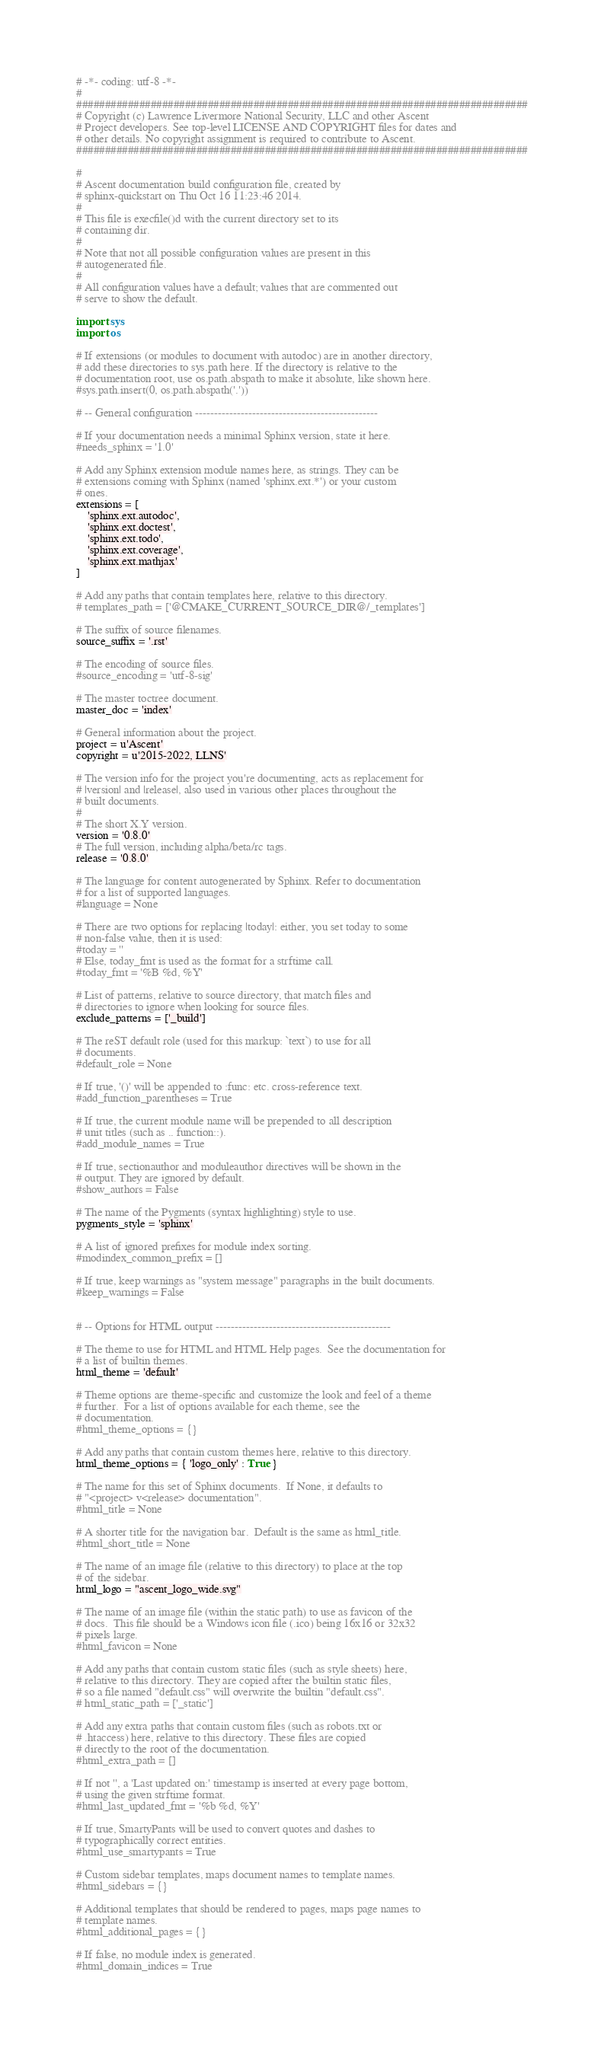Convert code to text. <code><loc_0><loc_0><loc_500><loc_500><_Python_># -*- coding: utf-8 -*-
#
###############################################################################
# Copyright (c) Lawrence Livermore National Security, LLC and other Ascent
# Project developers. See top-level LICENSE AND COPYRIGHT files for dates and
# other details. No copyright assignment is required to contribute to Ascent.
###############################################################################

#
# Ascent documentation build configuration file, created by
# sphinx-quickstart on Thu Oct 16 11:23:46 2014.
#
# This file is execfile()d with the current directory set to its
# containing dir.
#
# Note that not all possible configuration values are present in this
# autogenerated file.
#
# All configuration values have a default; values that are commented out
# serve to show the default.

import sys
import os

# If extensions (or modules to document with autodoc) are in another directory,
# add these directories to sys.path here. If the directory is relative to the
# documentation root, use os.path.abspath to make it absolute, like shown here.
#sys.path.insert(0, os.path.abspath('.'))

# -- General configuration ------------------------------------------------

# If your documentation needs a minimal Sphinx version, state it here.
#needs_sphinx = '1.0'

# Add any Sphinx extension module names here, as strings. They can be
# extensions coming with Sphinx (named 'sphinx.ext.*') or your custom
# ones.
extensions = [
    'sphinx.ext.autodoc',
    'sphinx.ext.doctest',
    'sphinx.ext.todo',
    'sphinx.ext.coverage',
    'sphinx.ext.mathjax'
]

# Add any paths that contain templates here, relative to this directory.
# templates_path = ['@CMAKE_CURRENT_SOURCE_DIR@/_templates']

# The suffix of source filenames.
source_suffix = '.rst'

# The encoding of source files.
#source_encoding = 'utf-8-sig'

# The master toctree document.
master_doc = 'index'

# General information about the project.
project = u'Ascent'
copyright = u'2015-2022, LLNS'

# The version info for the project you're documenting, acts as replacement for
# |version| and |release|, also used in various other places throughout the
# built documents.
#
# The short X.Y version.
version = '0.8.0'
# The full version, including alpha/beta/rc tags.
release = '0.8.0'

# The language for content autogenerated by Sphinx. Refer to documentation
# for a list of supported languages.
#language = None

# There are two options for replacing |today|: either, you set today to some
# non-false value, then it is used:
#today = ''
# Else, today_fmt is used as the format for a strftime call.
#today_fmt = '%B %d, %Y'

# List of patterns, relative to source directory, that match files and
# directories to ignore when looking for source files.
exclude_patterns = ['_build']

# The reST default role (used for this markup: `text`) to use for all
# documents.
#default_role = None

# If true, '()' will be appended to :func: etc. cross-reference text.
#add_function_parentheses = True

# If true, the current module name will be prepended to all description
# unit titles (such as .. function::).
#add_module_names = True

# If true, sectionauthor and moduleauthor directives will be shown in the
# output. They are ignored by default.
#show_authors = False

# The name of the Pygments (syntax highlighting) style to use.
pygments_style = 'sphinx'

# A list of ignored prefixes for module index sorting.
#modindex_common_prefix = []

# If true, keep warnings as "system message" paragraphs in the built documents.
#keep_warnings = False


# -- Options for HTML output ----------------------------------------------

# The theme to use for HTML and HTML Help pages.  See the documentation for
# a list of builtin themes.
html_theme = 'default'

# Theme options are theme-specific and customize the look and feel of a theme
# further.  For a list of options available for each theme, see the
# documentation.
#html_theme_options = {}

# Add any paths that contain custom themes here, relative to this directory.
html_theme_options = { 'logo_only' : True }

# The name for this set of Sphinx documents.  If None, it defaults to
# "<project> v<release> documentation".
#html_title = None

# A shorter title for the navigation bar.  Default is the same as html_title.
#html_short_title = None

# The name of an image file (relative to this directory) to place at the top
# of the sidebar.
html_logo = "ascent_logo_wide.svg"

# The name of an image file (within the static path) to use as favicon of the
# docs.  This file should be a Windows icon file (.ico) being 16x16 or 32x32
# pixels large.
#html_favicon = None

# Add any paths that contain custom static files (such as style sheets) here,
# relative to this directory. They are copied after the builtin static files,
# so a file named "default.css" will overwrite the builtin "default.css".
# html_static_path = ['_static']

# Add any extra paths that contain custom files (such as robots.txt or
# .htaccess) here, relative to this directory. These files are copied
# directly to the root of the documentation.
#html_extra_path = []

# If not '', a 'Last updated on:' timestamp is inserted at every page bottom,
# using the given strftime format.
#html_last_updated_fmt = '%b %d, %Y'

# If true, SmartyPants will be used to convert quotes and dashes to
# typographically correct entities.
#html_use_smartypants = True

# Custom sidebar templates, maps document names to template names.
#html_sidebars = {}

# Additional templates that should be rendered to pages, maps page names to
# template names.
#html_additional_pages = {}

# If false, no module index is generated.
#html_domain_indices = True
</code> 